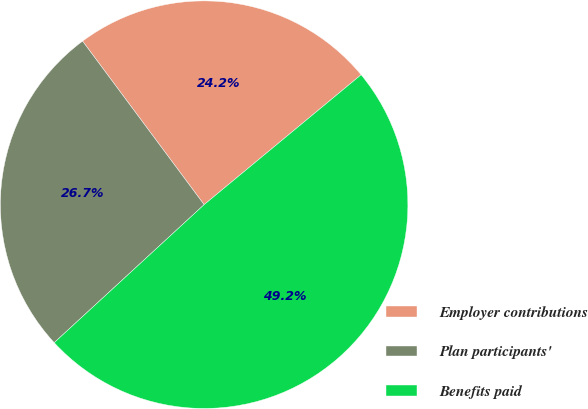Convert chart. <chart><loc_0><loc_0><loc_500><loc_500><pie_chart><fcel>Employer contributions<fcel>Plan participants'<fcel>Benefits paid<nl><fcel>24.17%<fcel>26.67%<fcel>49.16%<nl></chart> 